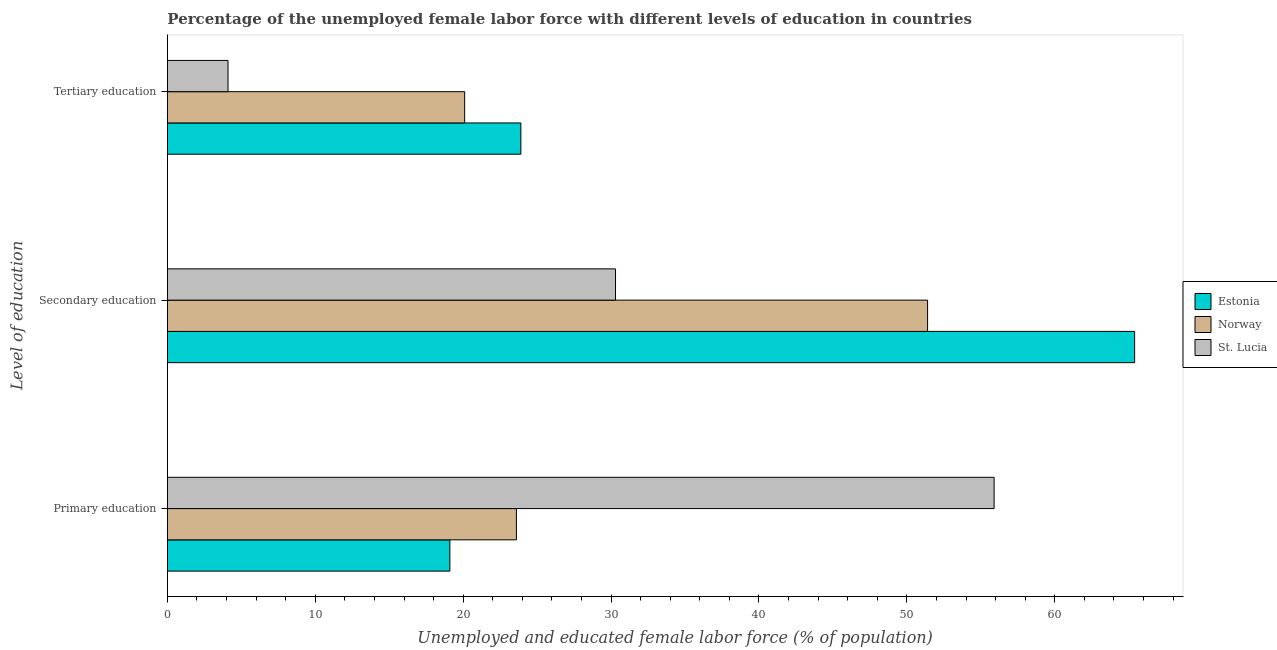How many different coloured bars are there?
Make the answer very short. 3. How many groups of bars are there?
Your answer should be compact. 3. Are the number of bars on each tick of the Y-axis equal?
Ensure brevity in your answer.  Yes. How many bars are there on the 3rd tick from the bottom?
Offer a terse response. 3. What is the label of the 1st group of bars from the top?
Provide a succinct answer. Tertiary education. What is the percentage of female labor force who received secondary education in Norway?
Your answer should be very brief. 51.4. Across all countries, what is the maximum percentage of female labor force who received secondary education?
Provide a succinct answer. 65.4. Across all countries, what is the minimum percentage of female labor force who received primary education?
Offer a terse response. 19.1. In which country was the percentage of female labor force who received secondary education maximum?
Offer a terse response. Estonia. In which country was the percentage of female labor force who received primary education minimum?
Ensure brevity in your answer.  Estonia. What is the total percentage of female labor force who received secondary education in the graph?
Provide a short and direct response. 147.1. What is the difference between the percentage of female labor force who received primary education in Estonia and that in Norway?
Your answer should be very brief. -4.5. What is the difference between the percentage of female labor force who received primary education in Estonia and the percentage of female labor force who received secondary education in Norway?
Offer a very short reply. -32.3. What is the average percentage of female labor force who received primary education per country?
Your answer should be very brief. 32.87. What is the difference between the percentage of female labor force who received primary education and percentage of female labor force who received tertiary education in St. Lucia?
Your response must be concise. 51.8. What is the ratio of the percentage of female labor force who received primary education in Norway to that in St. Lucia?
Your answer should be compact. 0.42. Is the percentage of female labor force who received secondary education in St. Lucia less than that in Estonia?
Offer a very short reply. Yes. What is the difference between the highest and the second highest percentage of female labor force who received tertiary education?
Offer a terse response. 3.8. What is the difference between the highest and the lowest percentage of female labor force who received secondary education?
Keep it short and to the point. 35.1. In how many countries, is the percentage of female labor force who received primary education greater than the average percentage of female labor force who received primary education taken over all countries?
Ensure brevity in your answer.  1. Is the sum of the percentage of female labor force who received secondary education in Estonia and St. Lucia greater than the maximum percentage of female labor force who received primary education across all countries?
Make the answer very short. Yes. What does the 1st bar from the bottom in Primary education represents?
Your response must be concise. Estonia. Is it the case that in every country, the sum of the percentage of female labor force who received primary education and percentage of female labor force who received secondary education is greater than the percentage of female labor force who received tertiary education?
Keep it short and to the point. Yes. Are all the bars in the graph horizontal?
Your answer should be very brief. Yes. Where does the legend appear in the graph?
Your answer should be compact. Center right. What is the title of the graph?
Make the answer very short. Percentage of the unemployed female labor force with different levels of education in countries. Does "Lao PDR" appear as one of the legend labels in the graph?
Give a very brief answer. No. What is the label or title of the X-axis?
Your answer should be very brief. Unemployed and educated female labor force (% of population). What is the label or title of the Y-axis?
Offer a very short reply. Level of education. What is the Unemployed and educated female labor force (% of population) in Estonia in Primary education?
Offer a very short reply. 19.1. What is the Unemployed and educated female labor force (% of population) in Norway in Primary education?
Give a very brief answer. 23.6. What is the Unemployed and educated female labor force (% of population) of St. Lucia in Primary education?
Provide a succinct answer. 55.9. What is the Unemployed and educated female labor force (% of population) of Estonia in Secondary education?
Offer a very short reply. 65.4. What is the Unemployed and educated female labor force (% of population) of Norway in Secondary education?
Provide a short and direct response. 51.4. What is the Unemployed and educated female labor force (% of population) of St. Lucia in Secondary education?
Your answer should be compact. 30.3. What is the Unemployed and educated female labor force (% of population) in Estonia in Tertiary education?
Offer a very short reply. 23.9. What is the Unemployed and educated female labor force (% of population) of Norway in Tertiary education?
Provide a short and direct response. 20.1. What is the Unemployed and educated female labor force (% of population) of St. Lucia in Tertiary education?
Keep it short and to the point. 4.1. Across all Level of education, what is the maximum Unemployed and educated female labor force (% of population) of Estonia?
Ensure brevity in your answer.  65.4. Across all Level of education, what is the maximum Unemployed and educated female labor force (% of population) of Norway?
Keep it short and to the point. 51.4. Across all Level of education, what is the maximum Unemployed and educated female labor force (% of population) of St. Lucia?
Offer a very short reply. 55.9. Across all Level of education, what is the minimum Unemployed and educated female labor force (% of population) of Estonia?
Provide a succinct answer. 19.1. Across all Level of education, what is the minimum Unemployed and educated female labor force (% of population) in Norway?
Keep it short and to the point. 20.1. Across all Level of education, what is the minimum Unemployed and educated female labor force (% of population) in St. Lucia?
Offer a very short reply. 4.1. What is the total Unemployed and educated female labor force (% of population) of Estonia in the graph?
Give a very brief answer. 108.4. What is the total Unemployed and educated female labor force (% of population) of Norway in the graph?
Your answer should be very brief. 95.1. What is the total Unemployed and educated female labor force (% of population) in St. Lucia in the graph?
Your answer should be compact. 90.3. What is the difference between the Unemployed and educated female labor force (% of population) of Estonia in Primary education and that in Secondary education?
Offer a terse response. -46.3. What is the difference between the Unemployed and educated female labor force (% of population) of Norway in Primary education and that in Secondary education?
Your answer should be very brief. -27.8. What is the difference between the Unemployed and educated female labor force (% of population) of St. Lucia in Primary education and that in Secondary education?
Your response must be concise. 25.6. What is the difference between the Unemployed and educated female labor force (% of population) in Estonia in Primary education and that in Tertiary education?
Give a very brief answer. -4.8. What is the difference between the Unemployed and educated female labor force (% of population) in Norway in Primary education and that in Tertiary education?
Ensure brevity in your answer.  3.5. What is the difference between the Unemployed and educated female labor force (% of population) of St. Lucia in Primary education and that in Tertiary education?
Ensure brevity in your answer.  51.8. What is the difference between the Unemployed and educated female labor force (% of population) of Estonia in Secondary education and that in Tertiary education?
Give a very brief answer. 41.5. What is the difference between the Unemployed and educated female labor force (% of population) of Norway in Secondary education and that in Tertiary education?
Make the answer very short. 31.3. What is the difference between the Unemployed and educated female labor force (% of population) in St. Lucia in Secondary education and that in Tertiary education?
Keep it short and to the point. 26.2. What is the difference between the Unemployed and educated female labor force (% of population) of Estonia in Primary education and the Unemployed and educated female labor force (% of population) of Norway in Secondary education?
Keep it short and to the point. -32.3. What is the difference between the Unemployed and educated female labor force (% of population) in Estonia in Primary education and the Unemployed and educated female labor force (% of population) in St. Lucia in Secondary education?
Offer a terse response. -11.2. What is the difference between the Unemployed and educated female labor force (% of population) of Estonia in Primary education and the Unemployed and educated female labor force (% of population) of Norway in Tertiary education?
Make the answer very short. -1. What is the difference between the Unemployed and educated female labor force (% of population) of Norway in Primary education and the Unemployed and educated female labor force (% of population) of St. Lucia in Tertiary education?
Give a very brief answer. 19.5. What is the difference between the Unemployed and educated female labor force (% of population) in Estonia in Secondary education and the Unemployed and educated female labor force (% of population) in Norway in Tertiary education?
Give a very brief answer. 45.3. What is the difference between the Unemployed and educated female labor force (% of population) in Estonia in Secondary education and the Unemployed and educated female labor force (% of population) in St. Lucia in Tertiary education?
Your response must be concise. 61.3. What is the difference between the Unemployed and educated female labor force (% of population) in Norway in Secondary education and the Unemployed and educated female labor force (% of population) in St. Lucia in Tertiary education?
Provide a short and direct response. 47.3. What is the average Unemployed and educated female labor force (% of population) of Estonia per Level of education?
Offer a very short reply. 36.13. What is the average Unemployed and educated female labor force (% of population) in Norway per Level of education?
Provide a short and direct response. 31.7. What is the average Unemployed and educated female labor force (% of population) in St. Lucia per Level of education?
Ensure brevity in your answer.  30.1. What is the difference between the Unemployed and educated female labor force (% of population) in Estonia and Unemployed and educated female labor force (% of population) in Norway in Primary education?
Your answer should be compact. -4.5. What is the difference between the Unemployed and educated female labor force (% of population) of Estonia and Unemployed and educated female labor force (% of population) of St. Lucia in Primary education?
Offer a terse response. -36.8. What is the difference between the Unemployed and educated female labor force (% of population) of Norway and Unemployed and educated female labor force (% of population) of St. Lucia in Primary education?
Give a very brief answer. -32.3. What is the difference between the Unemployed and educated female labor force (% of population) in Estonia and Unemployed and educated female labor force (% of population) in Norway in Secondary education?
Provide a succinct answer. 14. What is the difference between the Unemployed and educated female labor force (% of population) in Estonia and Unemployed and educated female labor force (% of population) in St. Lucia in Secondary education?
Give a very brief answer. 35.1. What is the difference between the Unemployed and educated female labor force (% of population) of Norway and Unemployed and educated female labor force (% of population) of St. Lucia in Secondary education?
Keep it short and to the point. 21.1. What is the difference between the Unemployed and educated female labor force (% of population) of Estonia and Unemployed and educated female labor force (% of population) of Norway in Tertiary education?
Your answer should be compact. 3.8. What is the difference between the Unemployed and educated female labor force (% of population) of Estonia and Unemployed and educated female labor force (% of population) of St. Lucia in Tertiary education?
Make the answer very short. 19.8. What is the ratio of the Unemployed and educated female labor force (% of population) in Estonia in Primary education to that in Secondary education?
Your answer should be compact. 0.29. What is the ratio of the Unemployed and educated female labor force (% of population) in Norway in Primary education to that in Secondary education?
Your answer should be compact. 0.46. What is the ratio of the Unemployed and educated female labor force (% of population) of St. Lucia in Primary education to that in Secondary education?
Ensure brevity in your answer.  1.84. What is the ratio of the Unemployed and educated female labor force (% of population) of Estonia in Primary education to that in Tertiary education?
Offer a very short reply. 0.8. What is the ratio of the Unemployed and educated female labor force (% of population) in Norway in Primary education to that in Tertiary education?
Your answer should be very brief. 1.17. What is the ratio of the Unemployed and educated female labor force (% of population) of St. Lucia in Primary education to that in Tertiary education?
Provide a short and direct response. 13.63. What is the ratio of the Unemployed and educated female labor force (% of population) of Estonia in Secondary education to that in Tertiary education?
Offer a terse response. 2.74. What is the ratio of the Unemployed and educated female labor force (% of population) in Norway in Secondary education to that in Tertiary education?
Your response must be concise. 2.56. What is the ratio of the Unemployed and educated female labor force (% of population) in St. Lucia in Secondary education to that in Tertiary education?
Ensure brevity in your answer.  7.39. What is the difference between the highest and the second highest Unemployed and educated female labor force (% of population) of Estonia?
Your answer should be compact. 41.5. What is the difference between the highest and the second highest Unemployed and educated female labor force (% of population) of Norway?
Provide a succinct answer. 27.8. What is the difference between the highest and the second highest Unemployed and educated female labor force (% of population) in St. Lucia?
Your response must be concise. 25.6. What is the difference between the highest and the lowest Unemployed and educated female labor force (% of population) in Estonia?
Keep it short and to the point. 46.3. What is the difference between the highest and the lowest Unemployed and educated female labor force (% of population) in Norway?
Ensure brevity in your answer.  31.3. What is the difference between the highest and the lowest Unemployed and educated female labor force (% of population) of St. Lucia?
Offer a very short reply. 51.8. 